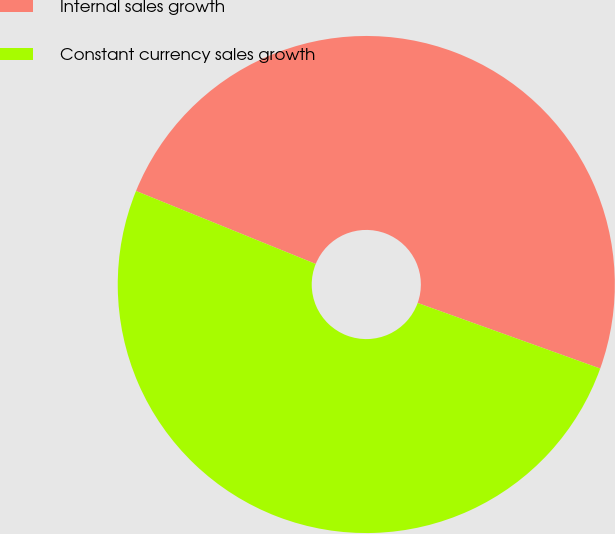<chart> <loc_0><loc_0><loc_500><loc_500><pie_chart><fcel>Internal sales growth<fcel>Constant currency sales growth<nl><fcel>49.35%<fcel>50.65%<nl></chart> 